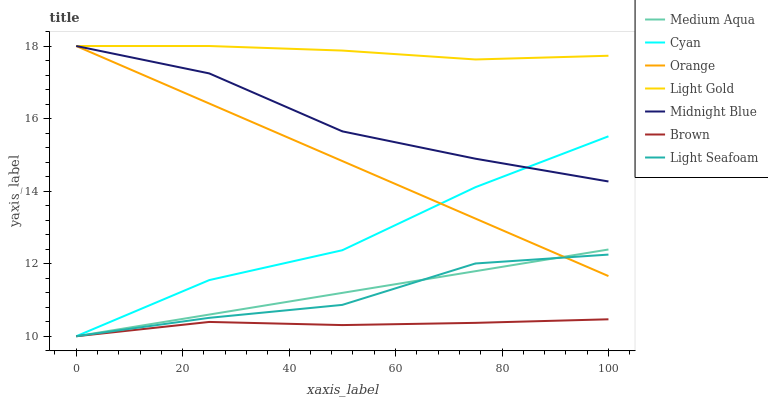Does Brown have the minimum area under the curve?
Answer yes or no. Yes. Does Light Gold have the maximum area under the curve?
Answer yes or no. Yes. Does Midnight Blue have the minimum area under the curve?
Answer yes or no. No. Does Midnight Blue have the maximum area under the curve?
Answer yes or no. No. Is Medium Aqua the smoothest?
Answer yes or no. Yes. Is Cyan the roughest?
Answer yes or no. Yes. Is Midnight Blue the smoothest?
Answer yes or no. No. Is Midnight Blue the roughest?
Answer yes or no. No. Does Midnight Blue have the lowest value?
Answer yes or no. No. Does Light Gold have the highest value?
Answer yes or no. Yes. Does Medium Aqua have the highest value?
Answer yes or no. No. Is Brown less than Orange?
Answer yes or no. Yes. Is Light Gold greater than Brown?
Answer yes or no. Yes. Does Light Seafoam intersect Brown?
Answer yes or no. Yes. Is Light Seafoam less than Brown?
Answer yes or no. No. Is Light Seafoam greater than Brown?
Answer yes or no. No. Does Brown intersect Orange?
Answer yes or no. No. 